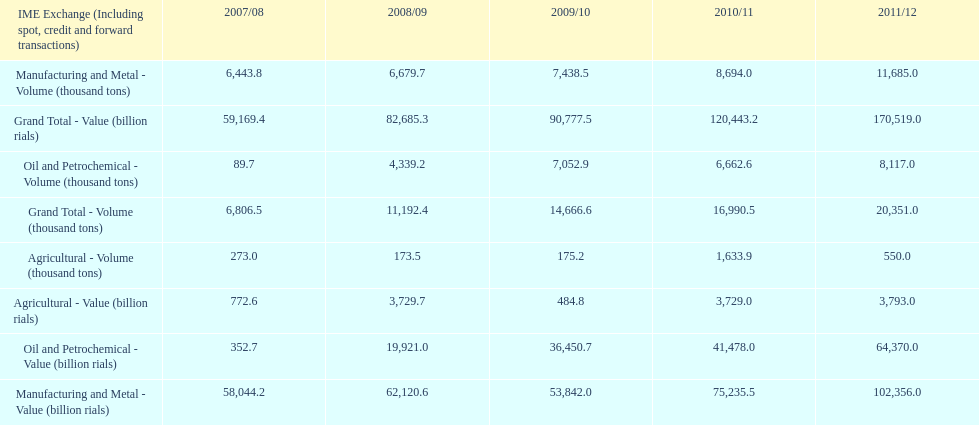Which year had the largest agricultural volume? 2010/11. 